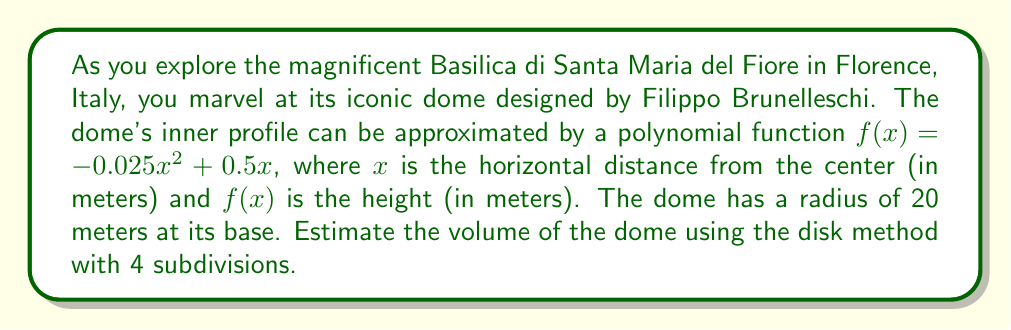Can you answer this question? To estimate the volume of the dome using the disk method with polynomial approximation, we'll follow these steps:

1) The disk method for volume is given by the formula:
   $$V = \pi \int_a^b [f(x)]^2 dx$$

2) We need to divide the interval [0, 20] into 4 equal subdivisions:
   $$\Delta x = \frac{20 - 0}{4} = 5$$

3) The x-values for our 4 disks will be:
   $x_1 = 2.5$, $x_2 = 7.5$, $x_3 = 12.5$, $x_4 = 17.5$

4) Calculate $f(x)$ for each x-value:
   $f(2.5) = -0.025(2.5)^2 + 0.5(2.5) = 1.09375$
   $f(7.5) = -0.025(7.5)^2 + 0.5(7.5) = 2.34375$
   $f(12.5) = -0.025(12.5)^2 + 0.5(12.5) = 2.65625$
   $f(17.5) = -0.025(17.5)^2 + 0.5(17.5) = 2.03125$

5) Calculate the volume of each disk:
   $V_1 = \pi [f(2.5)]^2 \Delta x = \pi (1.09375)^2 (5) = 18.8247$
   $V_2 = \pi [f(7.5)]^2 \Delta x = \pi (2.34375)^2 (5) = 86.2730$
   $V_3 = \pi [f(12.5)]^2 \Delta x = \pi (2.65625)^2 (5) = 110.7417$
   $V_4 = \pi [f(17.5)]^2 \Delta x = \pi (2.03125)^2 (5) = 64.8492$

6) Sum up the volumes of all disks:
   $V_{total} = V_1 + V_2 + V_3 + V_4 = 280.6886$

Therefore, the estimated volume of the dome is approximately 280.6886 cubic meters.
Answer: The estimated volume of the dome is approximately 280.69 cubic meters. 